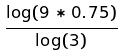<formula> <loc_0><loc_0><loc_500><loc_500>\frac { \log ( 9 * 0 . 7 5 ) } { \log ( 3 ) }</formula> 